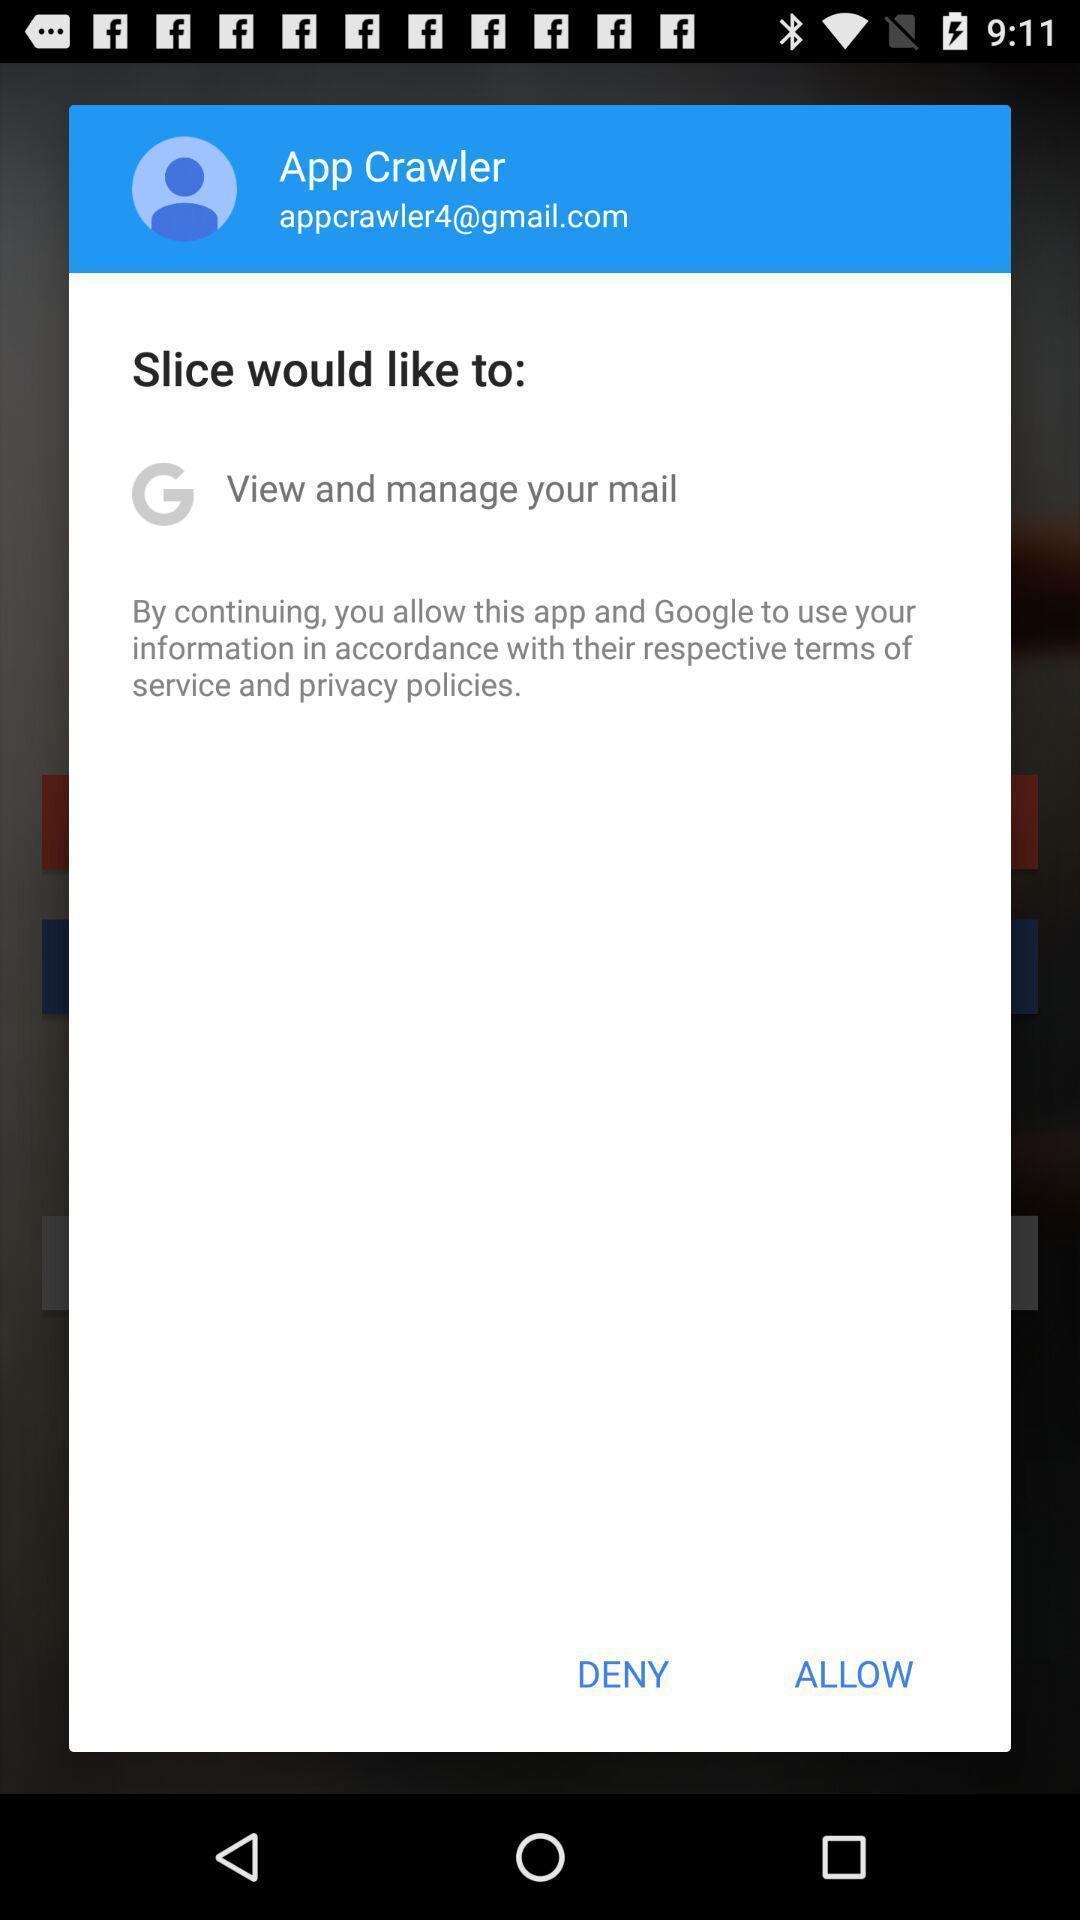Provide a textual representation of this image. Pop-up showing option like deny. 